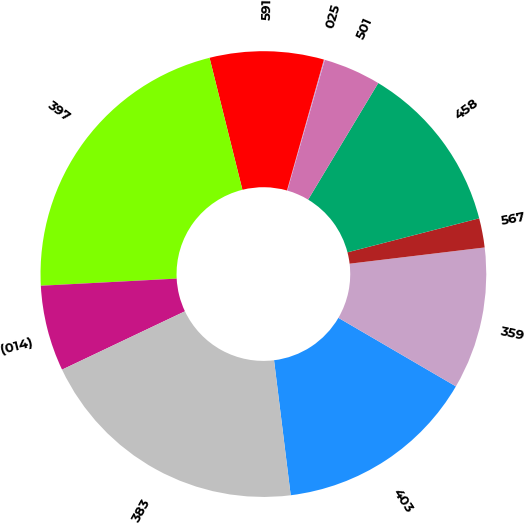Convert chart to OTSL. <chart><loc_0><loc_0><loc_500><loc_500><pie_chart><fcel>403<fcel>359<fcel>567<fcel>458<fcel>501<fcel>025<fcel>591<fcel>397<fcel>(014)<fcel>383<nl><fcel>14.64%<fcel>10.31%<fcel>2.12%<fcel>12.36%<fcel>4.17%<fcel>0.07%<fcel>8.26%<fcel>21.95%<fcel>6.22%<fcel>19.9%<nl></chart> 